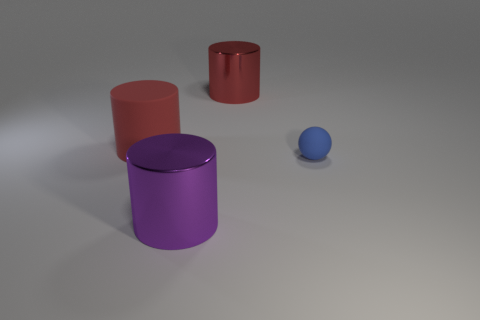Are there any other things that are the same size as the rubber sphere?
Your answer should be compact. No. Are there any other objects of the same shape as the big purple shiny thing?
Your answer should be very brief. Yes. What is the material of the tiny object?
Your answer should be very brief. Rubber. Are there any purple objects behind the small blue object?
Your answer should be compact. No. Is the shape of the large purple object the same as the large red matte object?
Offer a very short reply. Yes. What number of other objects are there of the same size as the purple shiny object?
Offer a very short reply. 2. What number of things are either large objects that are in front of the tiny object or red objects?
Keep it short and to the point. 3. What color is the rubber sphere?
Your answer should be very brief. Blue. What is the material of the large cylinder that is in front of the tiny rubber object?
Your answer should be very brief. Metal. Do the big purple shiny thing and the shiny object behind the blue matte sphere have the same shape?
Your answer should be compact. Yes. 